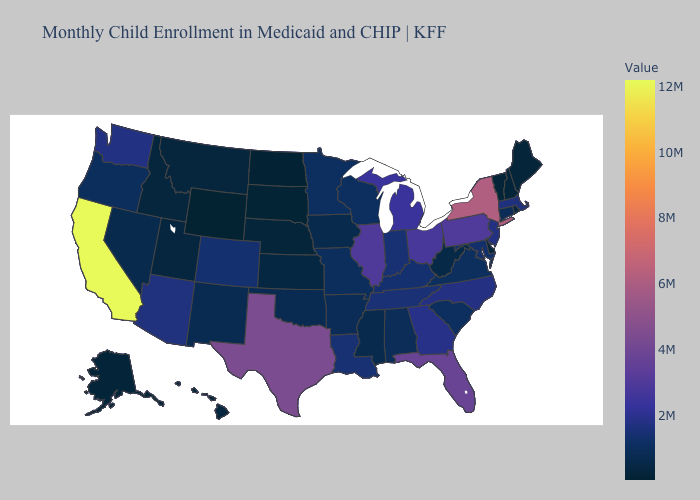Does Missouri have the lowest value in the MidWest?
Quick response, please. No. Which states hav the highest value in the MidWest?
Keep it brief. Illinois. Does California have the highest value in the USA?
Give a very brief answer. Yes. Does New Hampshire have the lowest value in the Northeast?
Give a very brief answer. No. 